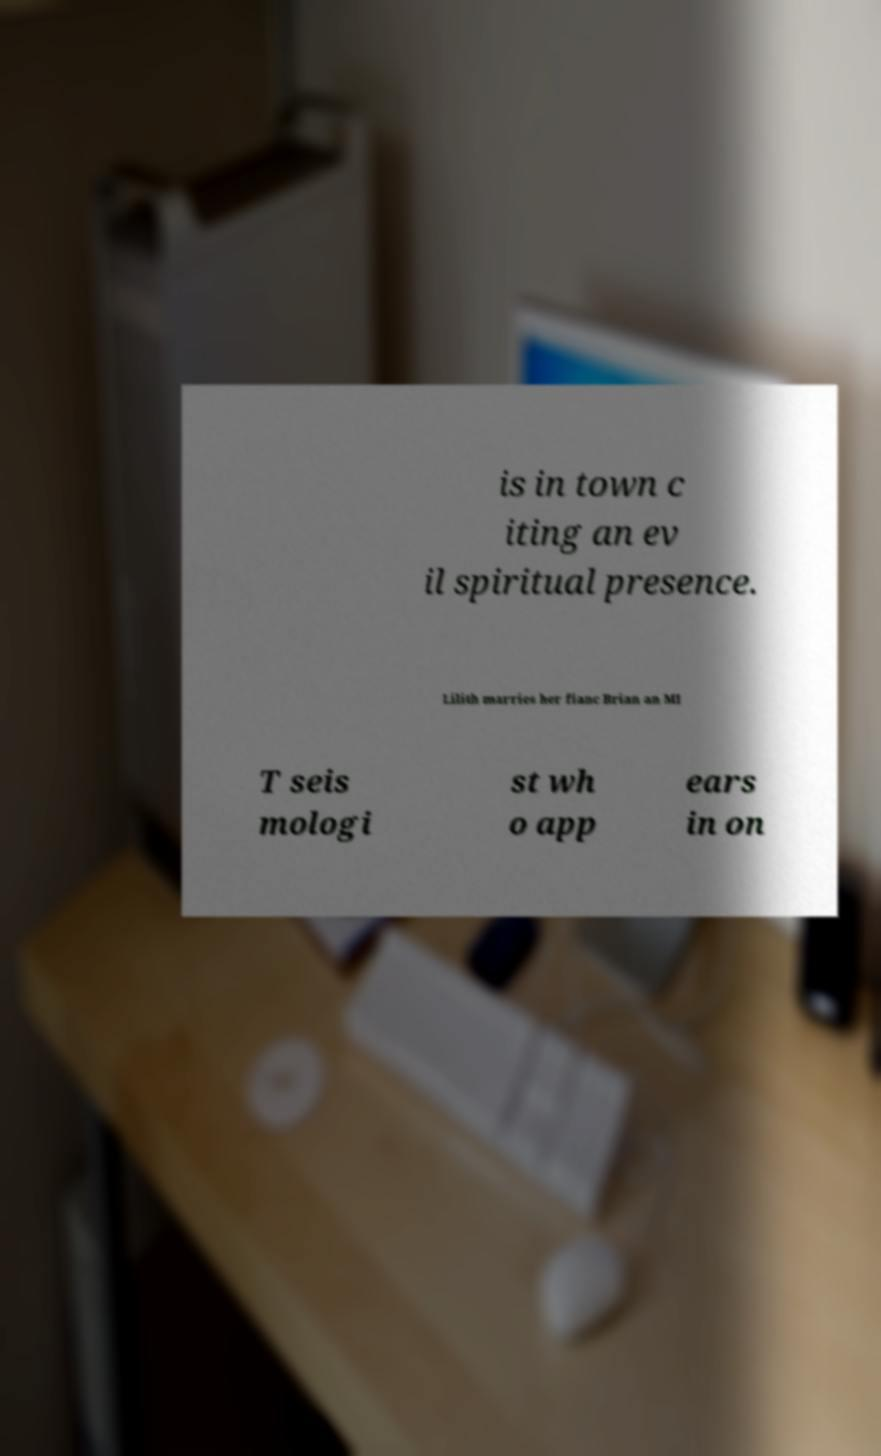For documentation purposes, I need the text within this image transcribed. Could you provide that? is in town c iting an ev il spiritual presence. Lilith marries her fianc Brian an MI T seis mologi st wh o app ears in on 